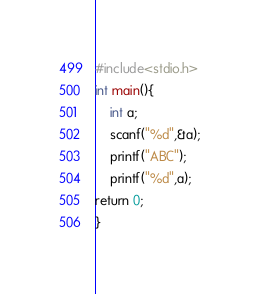<code> <loc_0><loc_0><loc_500><loc_500><_C_>#include<stdio.h>
int main(){
    int a;
    scanf("%d",&a);
    printf("ABC");
    printf("%d",a);
return 0;
}</code> 